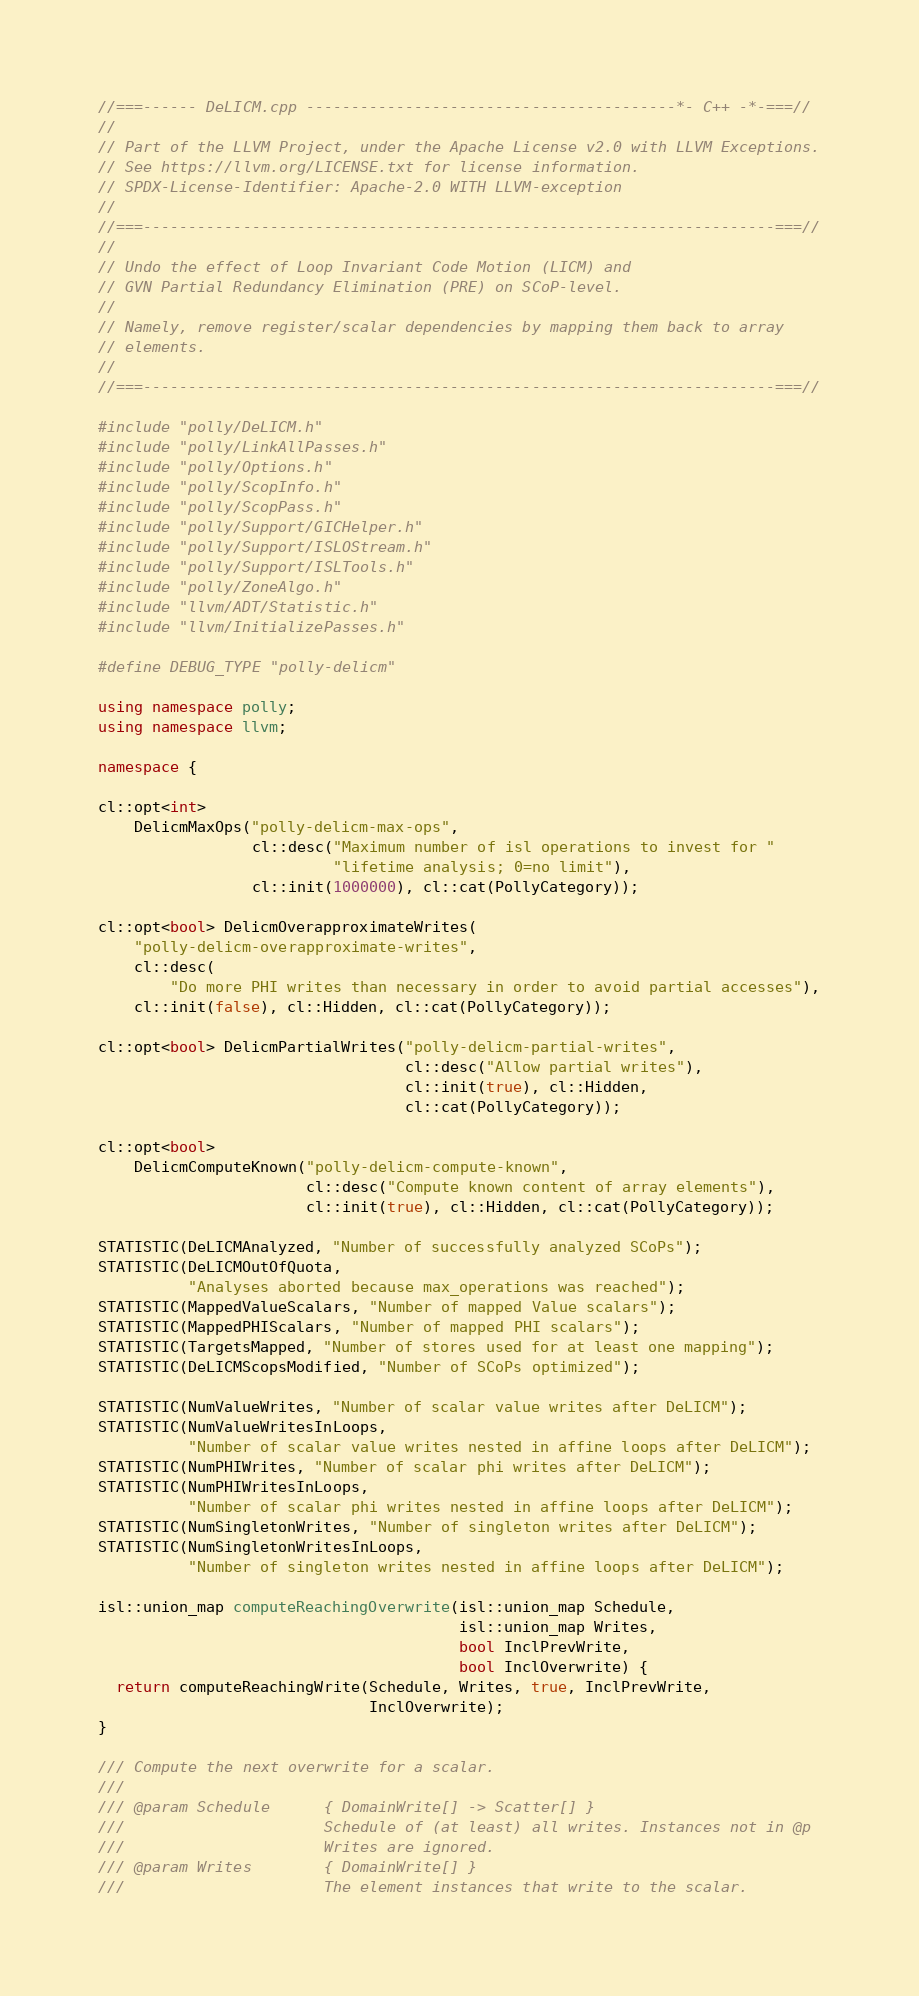Convert code to text. <code><loc_0><loc_0><loc_500><loc_500><_C++_>//===------ DeLICM.cpp -----------------------------------------*- C++ -*-===//
//
// Part of the LLVM Project, under the Apache License v2.0 with LLVM Exceptions.
// See https://llvm.org/LICENSE.txt for license information.
// SPDX-License-Identifier: Apache-2.0 WITH LLVM-exception
//
//===----------------------------------------------------------------------===//
//
// Undo the effect of Loop Invariant Code Motion (LICM) and
// GVN Partial Redundancy Elimination (PRE) on SCoP-level.
//
// Namely, remove register/scalar dependencies by mapping them back to array
// elements.
//
//===----------------------------------------------------------------------===//

#include "polly/DeLICM.h"
#include "polly/LinkAllPasses.h"
#include "polly/Options.h"
#include "polly/ScopInfo.h"
#include "polly/ScopPass.h"
#include "polly/Support/GICHelper.h"
#include "polly/Support/ISLOStream.h"
#include "polly/Support/ISLTools.h"
#include "polly/ZoneAlgo.h"
#include "llvm/ADT/Statistic.h"
#include "llvm/InitializePasses.h"

#define DEBUG_TYPE "polly-delicm"

using namespace polly;
using namespace llvm;

namespace {

cl::opt<int>
    DelicmMaxOps("polly-delicm-max-ops",
                 cl::desc("Maximum number of isl operations to invest for "
                          "lifetime analysis; 0=no limit"),
                 cl::init(1000000), cl::cat(PollyCategory));

cl::opt<bool> DelicmOverapproximateWrites(
    "polly-delicm-overapproximate-writes",
    cl::desc(
        "Do more PHI writes than necessary in order to avoid partial accesses"),
    cl::init(false), cl::Hidden, cl::cat(PollyCategory));

cl::opt<bool> DelicmPartialWrites("polly-delicm-partial-writes",
                                  cl::desc("Allow partial writes"),
                                  cl::init(true), cl::Hidden,
                                  cl::cat(PollyCategory));

cl::opt<bool>
    DelicmComputeKnown("polly-delicm-compute-known",
                       cl::desc("Compute known content of array elements"),
                       cl::init(true), cl::Hidden, cl::cat(PollyCategory));

STATISTIC(DeLICMAnalyzed, "Number of successfully analyzed SCoPs");
STATISTIC(DeLICMOutOfQuota,
          "Analyses aborted because max_operations was reached");
STATISTIC(MappedValueScalars, "Number of mapped Value scalars");
STATISTIC(MappedPHIScalars, "Number of mapped PHI scalars");
STATISTIC(TargetsMapped, "Number of stores used for at least one mapping");
STATISTIC(DeLICMScopsModified, "Number of SCoPs optimized");

STATISTIC(NumValueWrites, "Number of scalar value writes after DeLICM");
STATISTIC(NumValueWritesInLoops,
          "Number of scalar value writes nested in affine loops after DeLICM");
STATISTIC(NumPHIWrites, "Number of scalar phi writes after DeLICM");
STATISTIC(NumPHIWritesInLoops,
          "Number of scalar phi writes nested in affine loops after DeLICM");
STATISTIC(NumSingletonWrites, "Number of singleton writes after DeLICM");
STATISTIC(NumSingletonWritesInLoops,
          "Number of singleton writes nested in affine loops after DeLICM");

isl::union_map computeReachingOverwrite(isl::union_map Schedule,
                                        isl::union_map Writes,
                                        bool InclPrevWrite,
                                        bool InclOverwrite) {
  return computeReachingWrite(Schedule, Writes, true, InclPrevWrite,
                              InclOverwrite);
}

/// Compute the next overwrite for a scalar.
///
/// @param Schedule      { DomainWrite[] -> Scatter[] }
///                      Schedule of (at least) all writes. Instances not in @p
///                      Writes are ignored.
/// @param Writes        { DomainWrite[] }
///                      The element instances that write to the scalar.</code> 